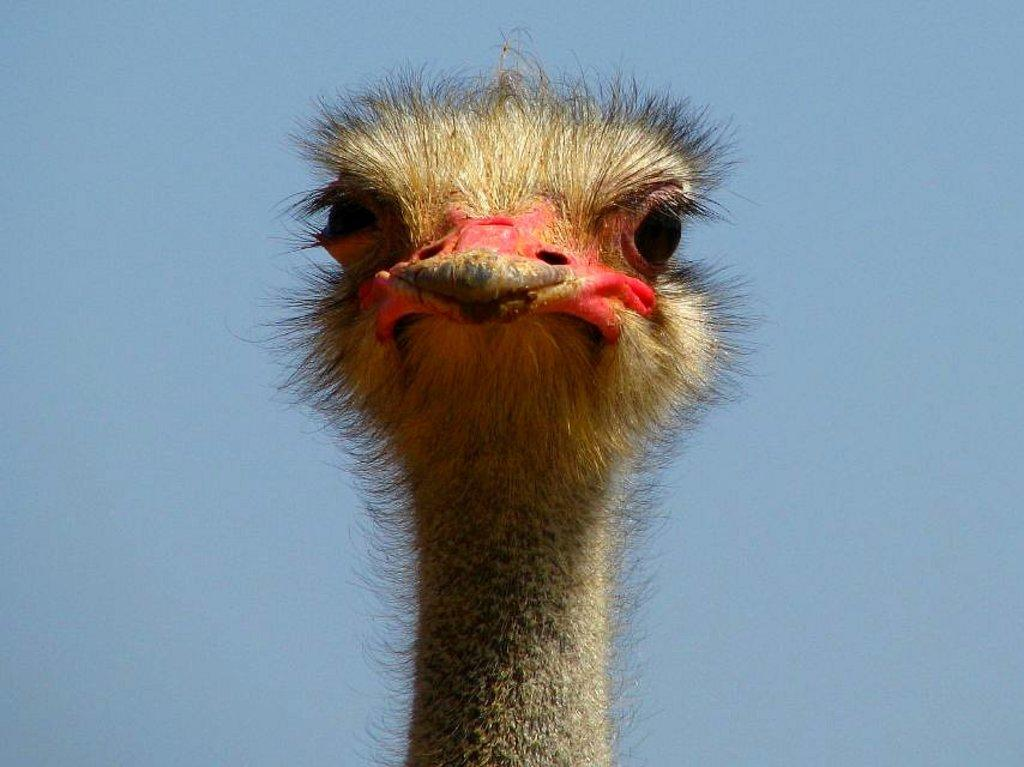What animal is the main subject of the picture? There is an ostrich in the picture. What is the color of the ostrich's hair? The ostrich has cream-colored hair. What facial features does the ostrich have? The ostrich has eyes and a beak. What can be seen in the background of the picture? The sky is visible in the background of the picture. What is the color of the sky in the image? The sky is blue in color. Where is the crate located in the image? There is no crate present in the image. What type of cake is being served on the dock in the image? There is no cake or dock present in the image; it features an ostrich with a blue sky in the background. 